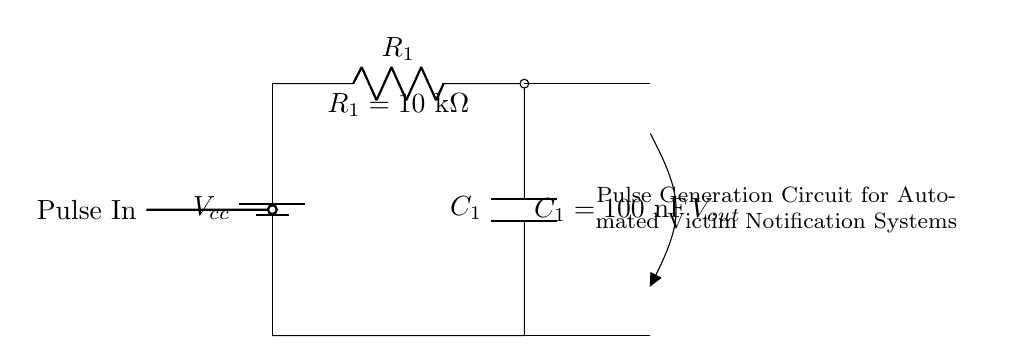What is the value of the resistor in this circuit? The resistor value is directly labeled in the circuit diagram as R1 equals ten kilo-ohms.
Answer: ten kilo-ohms What is the capacitance value in this circuit? The capacitance value is indicated on the circuit as C1 equals one hundred nanofarads.
Answer: one hundred nanofarads What does the R-C circuit generate at the output? The output voltage, labeled as Vout, is a pulse signal that arises from the charging and discharging of the capacitor through the resistor.
Answer: pulse signal How does the resistor and capacitor affect pulse duration? The resistor and capacitor create a time constant through their values, which determines the rate of charging and discharging. The time constant is calculated as the product of the resistor and capacitor values, leading to longer pulse durations with higher values.
Answer: time constant What is the relationship between R1 and C1 in terms of time response? The product of R1 and C1 defines the time constant, directly affecting the rise and fall times of the output pulse, thereby controlling how quickly the circuit reacts to the input pulses.
Answer: controlling reaction time What is the purpose of this circuit in an automated victim notification system? The pulse generation circuit is designed to send out notifications quickly in response to an event, ensuring timely alerts in critical situations, enhancing the safety and communication for victims.
Answer: timely alerts What type of input signal is required for this circuit? The circuit requires a pulse input as indicated in the diagram, which initiates the charging process of the capacitor to generate an output pulse.
Answer: pulse input 